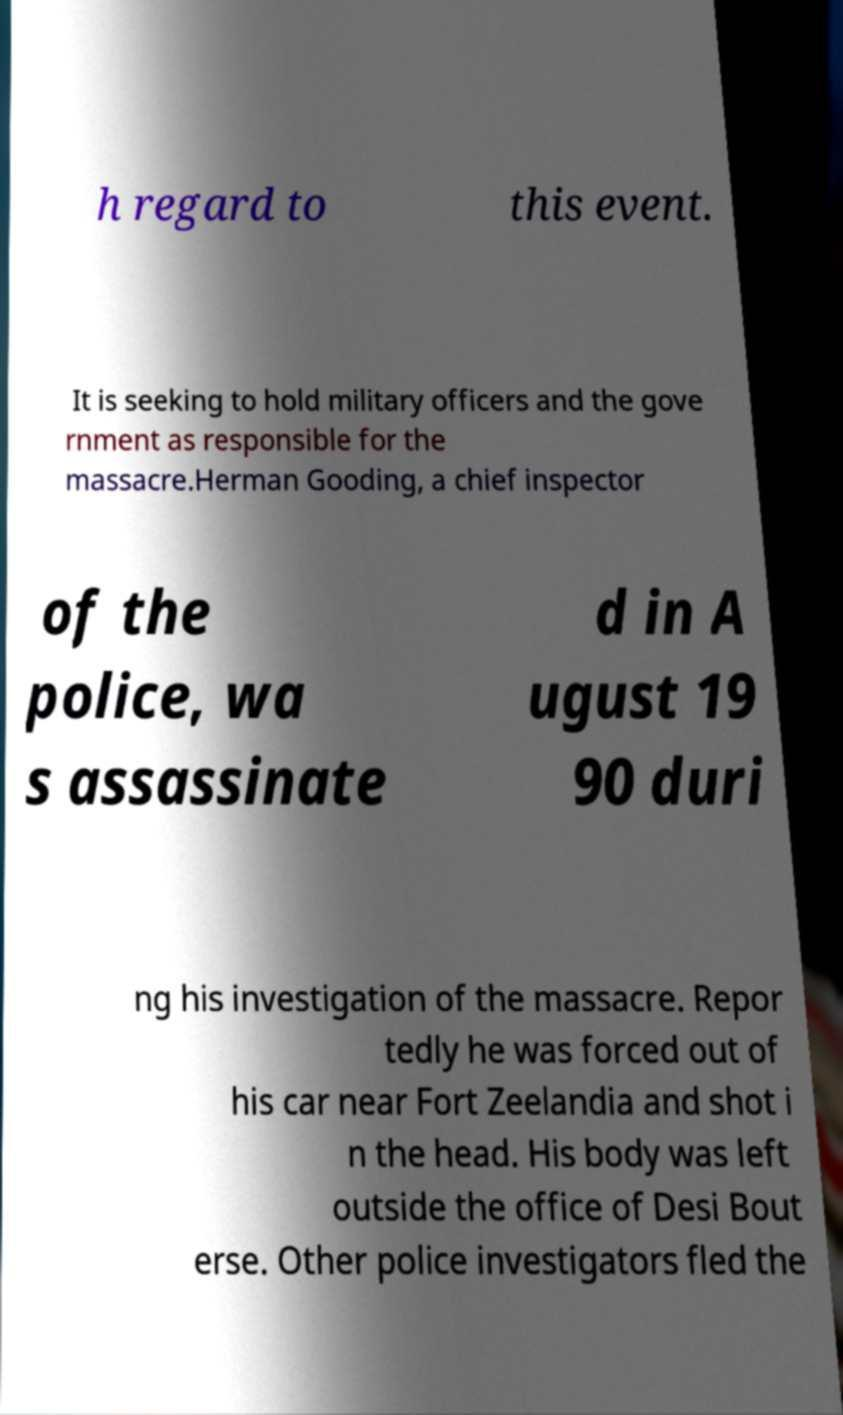For documentation purposes, I need the text within this image transcribed. Could you provide that? h regard to this event. It is seeking to hold military officers and the gove rnment as responsible for the massacre.Herman Gooding, a chief inspector of the police, wa s assassinate d in A ugust 19 90 duri ng his investigation of the massacre. Repor tedly he was forced out of his car near Fort Zeelandia and shot i n the head. His body was left outside the office of Desi Bout erse. Other police investigators fled the 